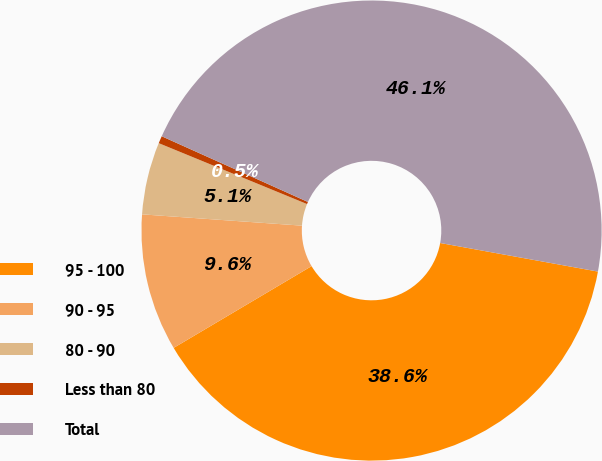Convert chart to OTSL. <chart><loc_0><loc_0><loc_500><loc_500><pie_chart><fcel>95 - 100<fcel>90 - 95<fcel>80 - 90<fcel>Less than 80<fcel>Total<nl><fcel>38.63%<fcel>9.64%<fcel>5.08%<fcel>0.52%<fcel>46.13%<nl></chart> 